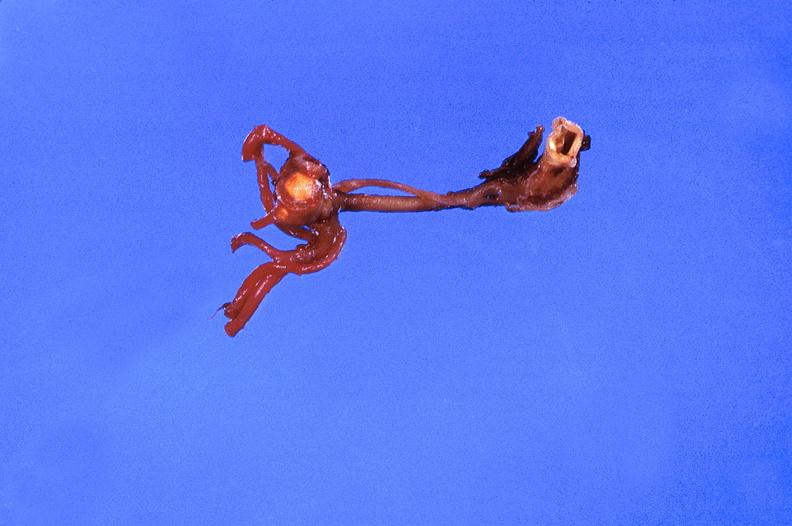what is present?
Answer the question using a single word or phrase. Cardiovascular 